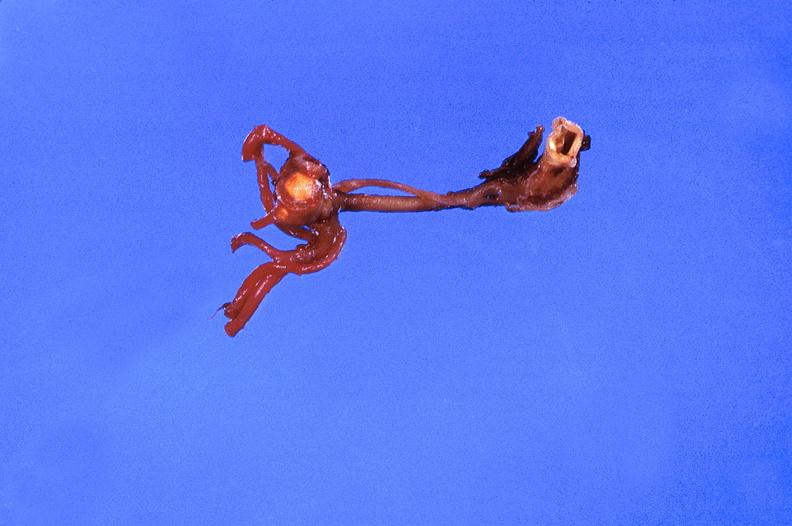what is present?
Answer the question using a single word or phrase. Cardiovascular 